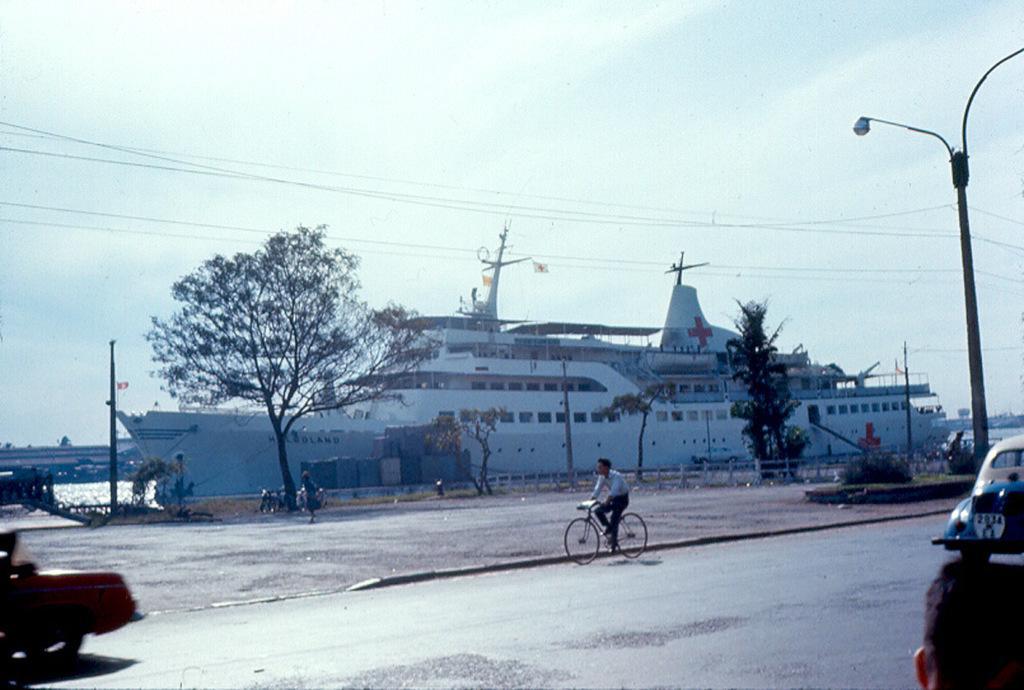Can you describe this image briefly? In this image we can see a ship, water, sky with clouds, cables, street poles, street lights, trees, motor vehicles and a person riding bicycle on the road. 